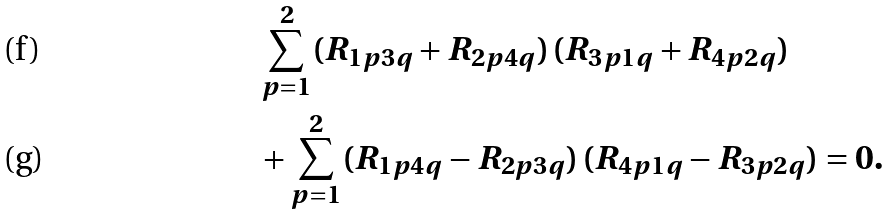Convert formula to latex. <formula><loc_0><loc_0><loc_500><loc_500>& \sum _ { p = 1 } ^ { 2 } ( R _ { 1 p 3 q } + R _ { 2 p 4 q } ) \, ( R _ { 3 p 1 q } + R _ { 4 p 2 q } ) \\ & + \sum _ { p = 1 } ^ { 2 } ( R _ { 1 p 4 q } - R _ { 2 p 3 q } ) \, ( R _ { 4 p 1 q } - R _ { 3 p 2 q } ) = 0 .</formula> 